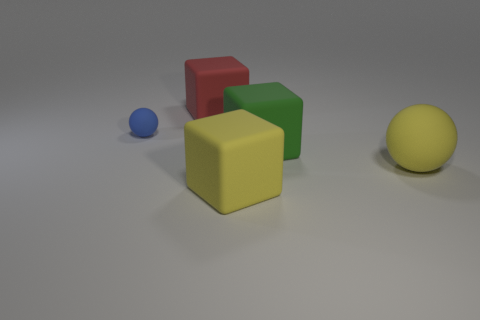Add 4 purple matte balls. How many objects exist? 9 Subtract all blocks. How many objects are left? 2 Subtract 1 yellow cubes. How many objects are left? 4 Subtract all small matte things. Subtract all brown balls. How many objects are left? 4 Add 5 yellow matte things. How many yellow matte things are left? 7 Add 5 large yellow matte spheres. How many large yellow matte spheres exist? 6 